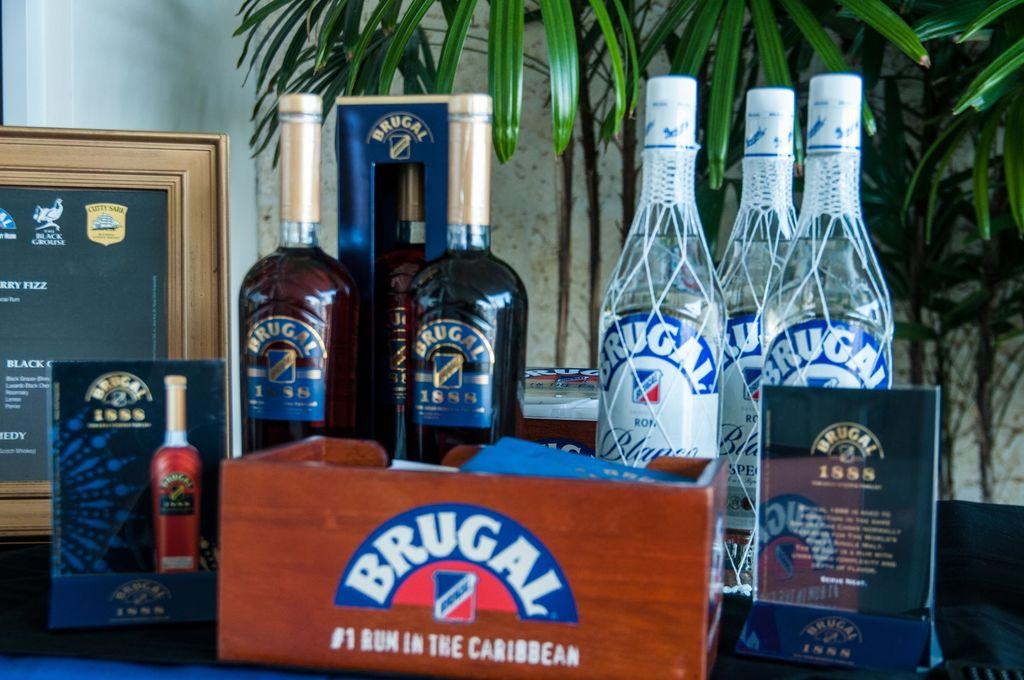<image>
Provide a brief description of the given image. Bottles of Brugal alcohol are placed on a table in front of a plant. 